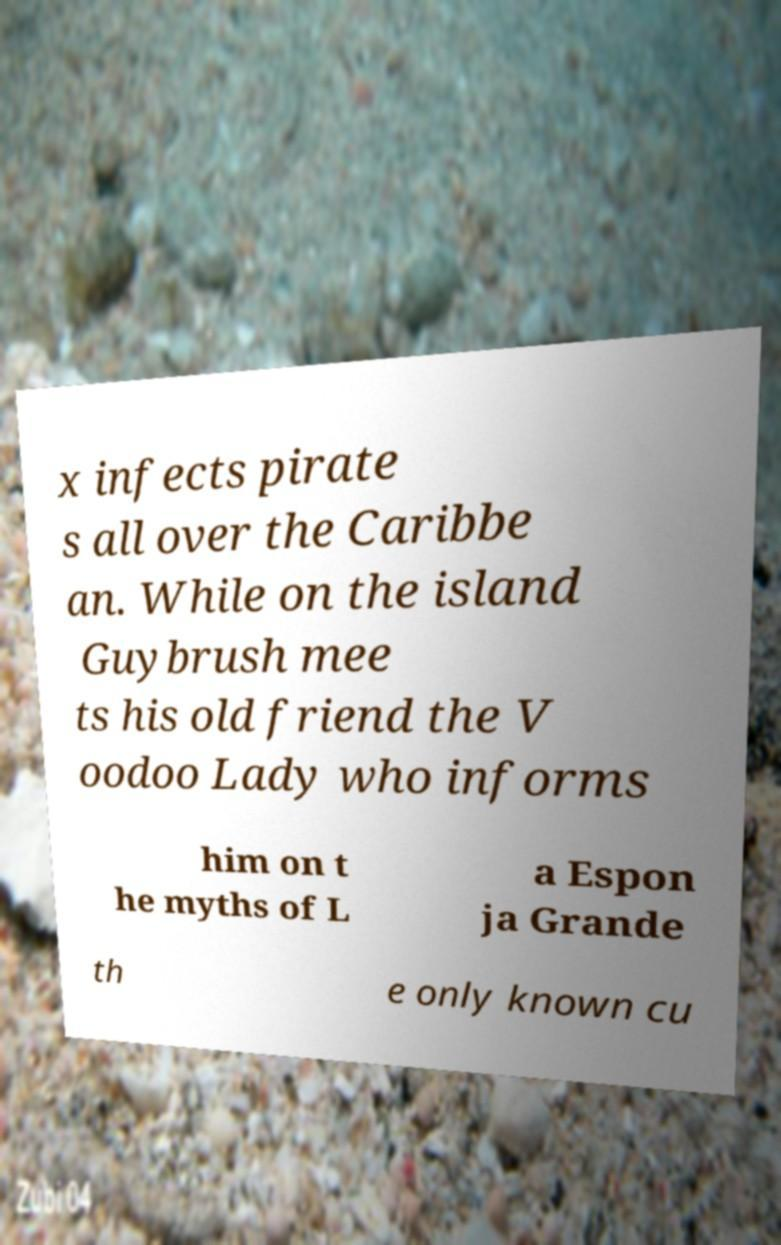Could you assist in decoding the text presented in this image and type it out clearly? x infects pirate s all over the Caribbe an. While on the island Guybrush mee ts his old friend the V oodoo Lady who informs him on t he myths of L a Espon ja Grande th e only known cu 